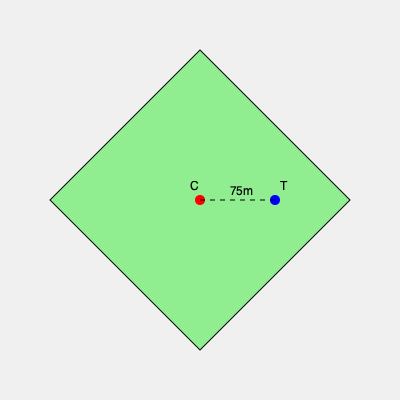You're designing a campsite layout for an expedition booking app. The site is a square with diagonals of 300m each. If a central campfire (C) is placed at the center and a tent (T) is positioned 75m away from the center along one of the diagonals, what is the shortest distance from the tent to any edge of the campsite? Let's approach this step-by-step:

1) First, we need to understand the geometry of the campsite:
   - It's a square with diagonals of 300m.
   - The campfire (C) is at the center.
   - The tent (T) is 75m away from the center along a diagonal.

2) In a square, diagonals bisect each other at right angles. So, the distance from the center to any corner is half the diagonal length:
   $\frac{300}{2} = 150m$

3) The square's side length can be calculated using the Pythagorean theorem:
   $s^2 + s^2 = 300^2$
   $2s^2 = 90000$
   $s^2 = 45000$
   $s = \sqrt{45000} \approx 212.13m$

4) Now, let's focus on the triangle formed by the center (C), the tent (T), and the nearest point on the edge of the square.
   - We know CT = 75m
   - We need to find the perpendicular distance from T to the edge.

5) The distance from C to the edge is half the side length:
   $\frac{212.13}{2} \approx 106.07m$

6) We can use the Pythagorean theorem again:
   Let x be the distance from T to the edge.
   $x^2 + 75^2 = 106.07^2$
   $x^2 = 106.07^2 - 75^2$
   $x^2 = 11250 - 5625 = 5625$
   $x = \sqrt{5625} = 75m$

Therefore, the shortest distance from the tent to any edge of the campsite is 75m.
Answer: 75m 